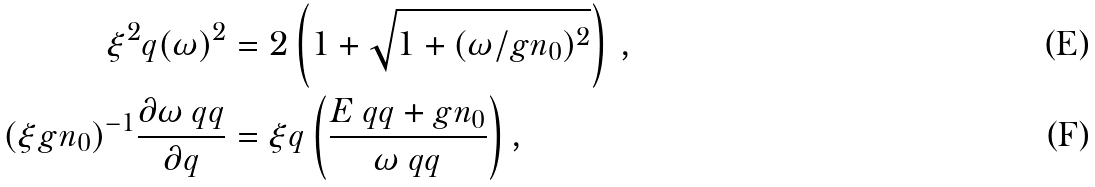Convert formula to latex. <formula><loc_0><loc_0><loc_500><loc_500>\xi ^ { 2 } q ( \omega ) ^ { 2 } & = 2 \left ( 1 + \sqrt { 1 + ( \omega / g n _ { 0 } ) ^ { 2 } } \right ) \, , \\ ( \xi g n _ { 0 } ) ^ { - 1 } \frac { \partial \omega _ { \ } q q } { \partial q } & = \xi q \left ( \frac { E _ { \ } q q + g n _ { 0 } } { \omega _ { \ } q q } \right ) ,</formula> 